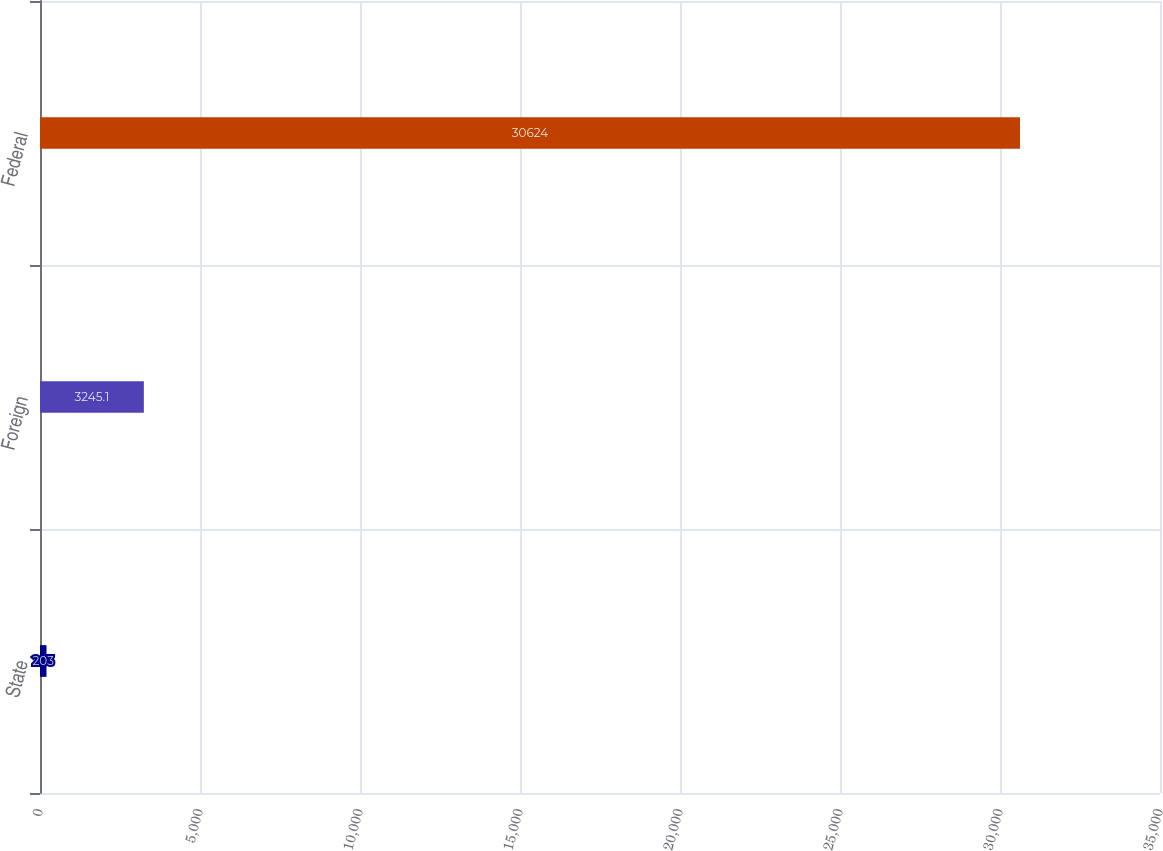Convert chart. <chart><loc_0><loc_0><loc_500><loc_500><bar_chart><fcel>State<fcel>Foreign<fcel>Federal<nl><fcel>203<fcel>3245.1<fcel>30624<nl></chart> 